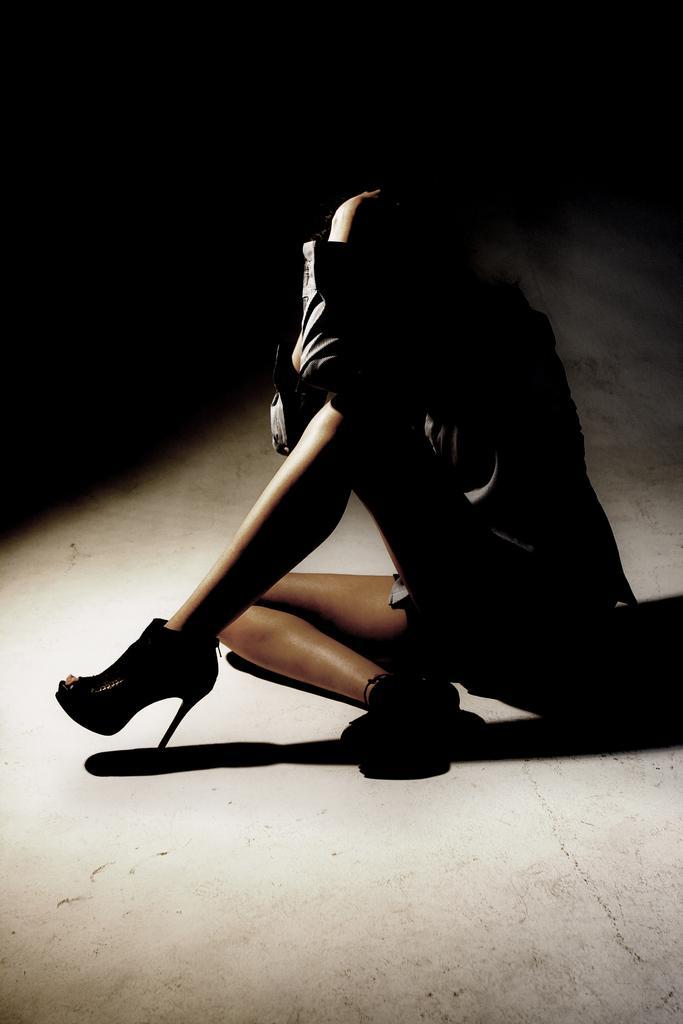Could you give a brief overview of what you see in this image? In the center of this picture we can see a person wearing heels and sitting on the ground. The background of the image is dark. 